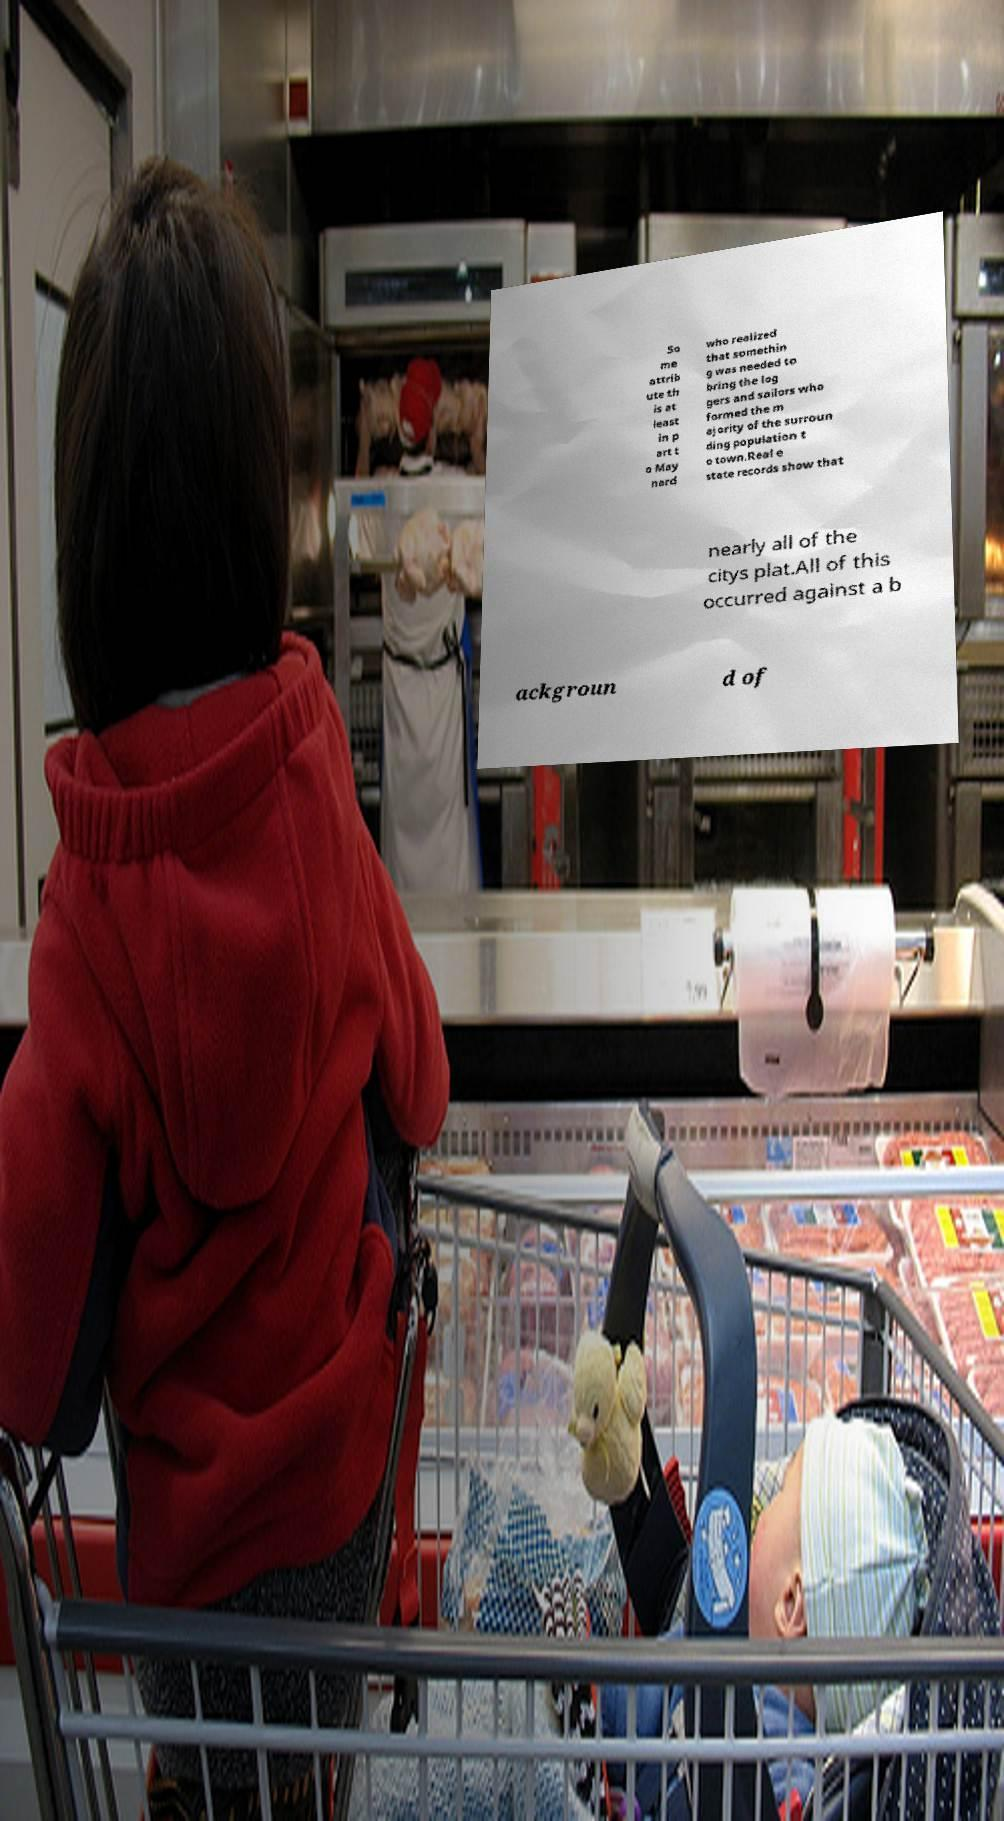I need the written content from this picture converted into text. Can you do that? So me attrib ute th is at least in p art t o May nard who realized that somethin g was needed to bring the log gers and sailors who formed the m ajority of the surroun ding population t o town.Real e state records show that nearly all of the citys plat.All of this occurred against a b ackgroun d of 